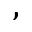Convert formula to latex. <formula><loc_0><loc_0><loc_500><loc_500>,</formula> 